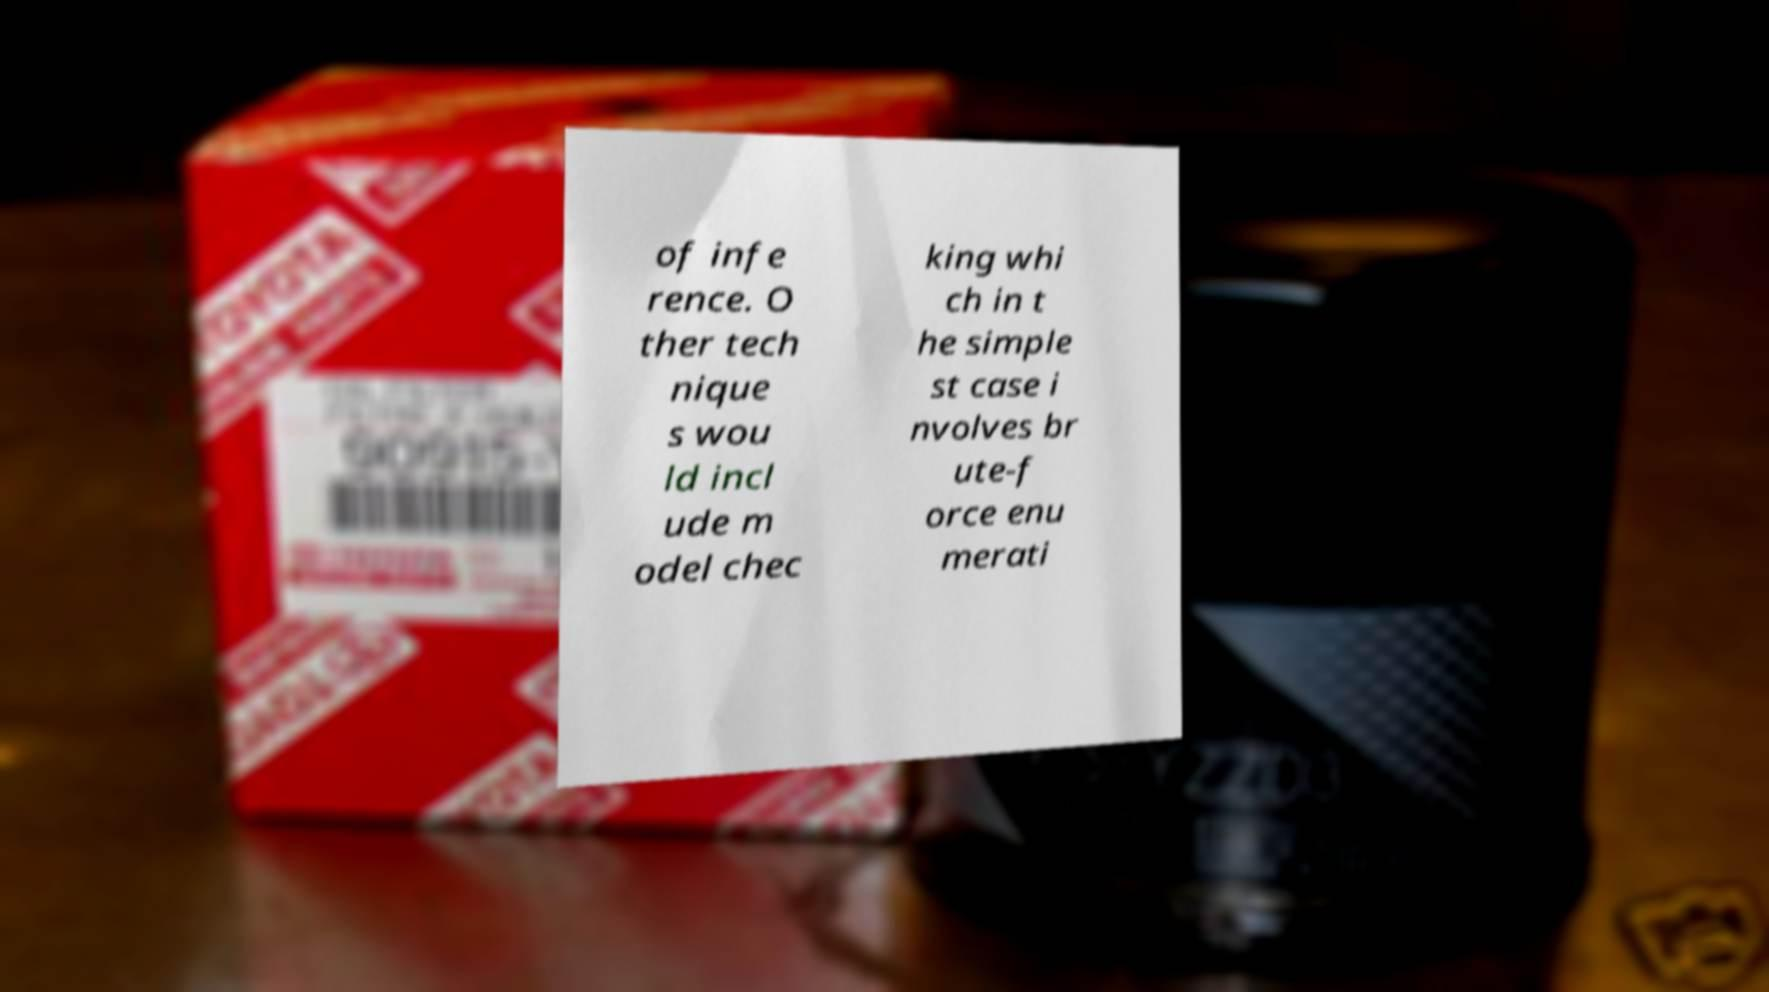There's text embedded in this image that I need extracted. Can you transcribe it verbatim? of infe rence. O ther tech nique s wou ld incl ude m odel chec king whi ch in t he simple st case i nvolves br ute-f orce enu merati 